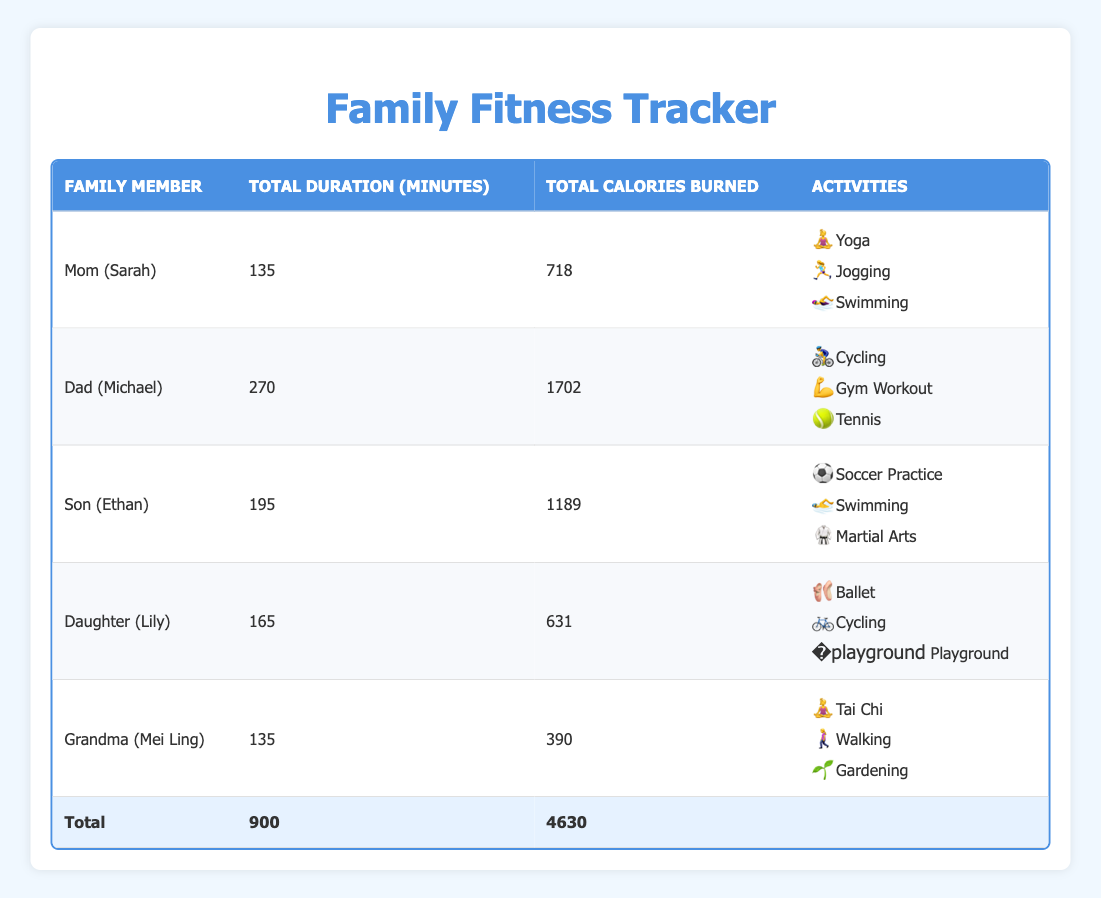What is the total duration of physical activity for Dad (Michael)? From the table, Dad (Michael) has three activities: Cycling for 60 minutes, Gym Workout for 90 minutes, and Tennis for 120 minutes. Summing these gives 60 + 90 + 120 = 270 minutes.
Answer: 270 minutes How many calories did Daughter (Lily) burn in total? Looking at the data for Daughter (Lily), she has three activities: Ballet burning 263 calories, Cycling burning 158 calories, and Playground burning 210 calories. Adding these gives 263 + 158 + 210 = 631 calories.
Answer: 631 calories Did Grandma (Mei Ling) participate in more than 2 activities? Referring to the table, Grandma (Mei Ling) performed 3 activities: Tai Chi, Walking, and Gardening. Since 3 is greater than 2, the answer is true.
Answer: Yes Which family member burned the most calories in total? By checking the total calories burned, we see that Dad (Michael) burned 1702 calories, Son (Ethan) burned 1189 calories, Mom (Sarah) burned 718 calories, Daughter (Lily) burned 631 calories, and Grandma (Mei Ling) burned 390 calories. Dad (Michael) has the highest at 1702 calories.
Answer: Dad (Michael) What is the average duration of physical activity for the family? To find the average, first, sum all activity durations: 135 (Mom) + 270 (Dad) + 195 (Son) + 165 (Daughter) + 135 (Grandma) = 900 minutes, and then divide by the number of family members (5): 900/5 = 180 minutes.
Answer: 180 minutes How many activities involved swimming? From the table, we see two family members involved in swimming: Mom (Sarah) with 1 swimming activity and Son (Ethan) with another swimming activity, thus totaling 2 activities.
Answer: 2 activities What activities did Son (Ethan) perform? Reviewing the table under Son (Ethan), he participated in Soccer Practice, Swimming, and Martial Arts, thus listing these gives us the activities he performed.
Answer: Soccer Practice, Swimming, Martial Arts Was the total duration of Grandma (Mei Ling)'s activities greater than Mom (Sarah)'s? Grandma (Mei Ling) has a total duration of 135 minutes and Mom (Sarah) has 135 minutes as well. Both totals are equal, thus it is false.
Answer: No 